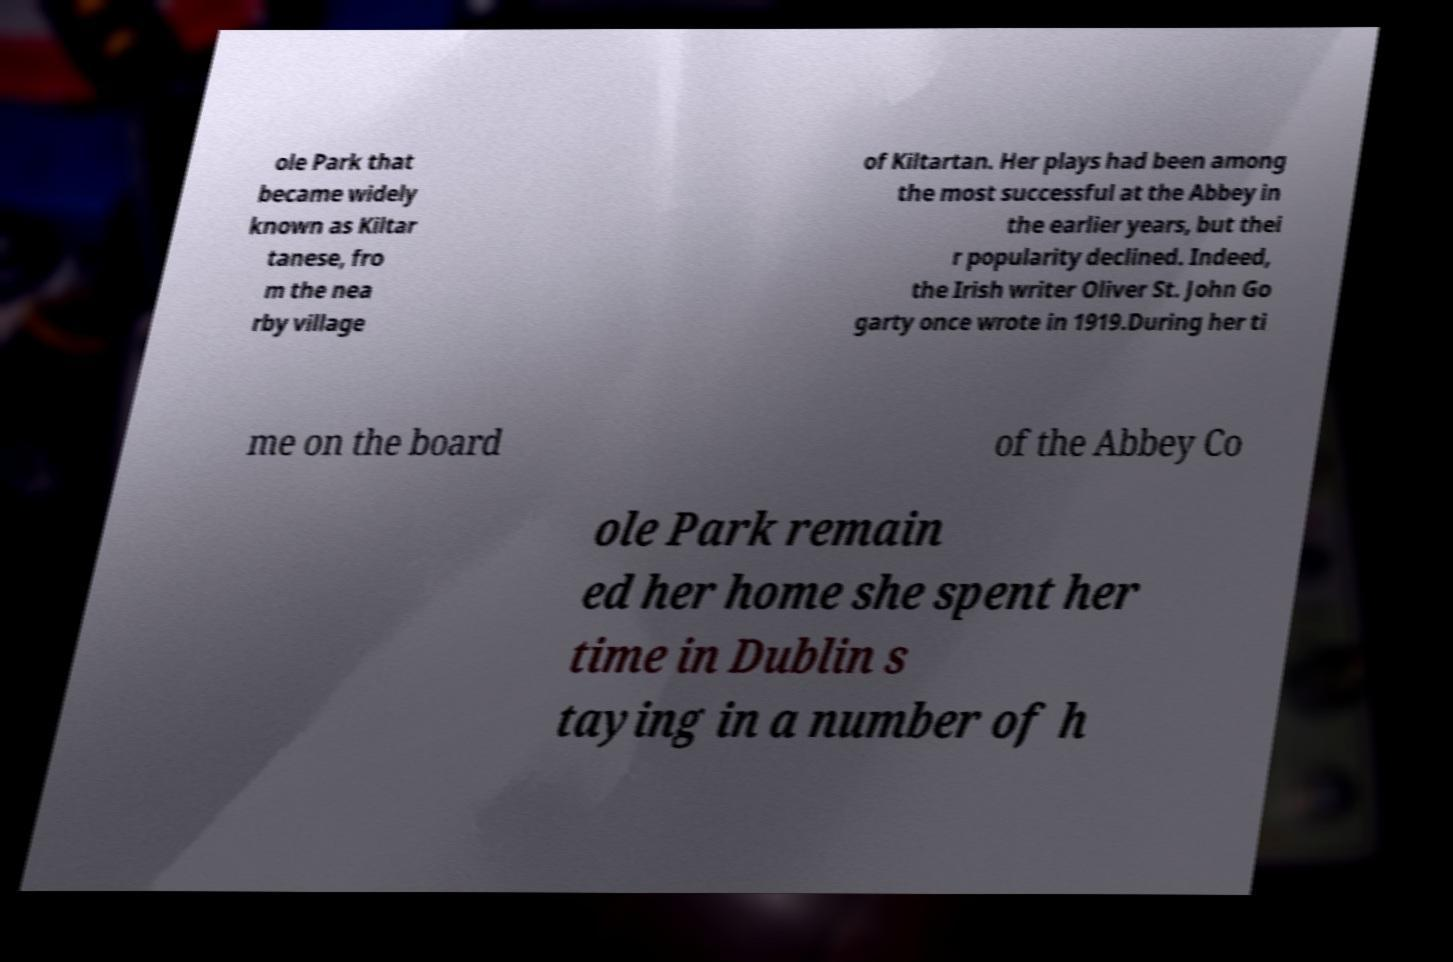Please identify and transcribe the text found in this image. ole Park that became widely known as Kiltar tanese, fro m the nea rby village of Kiltartan. Her plays had been among the most successful at the Abbey in the earlier years, but thei r popularity declined. Indeed, the Irish writer Oliver St. John Go garty once wrote in 1919.During her ti me on the board of the Abbey Co ole Park remain ed her home she spent her time in Dublin s taying in a number of h 